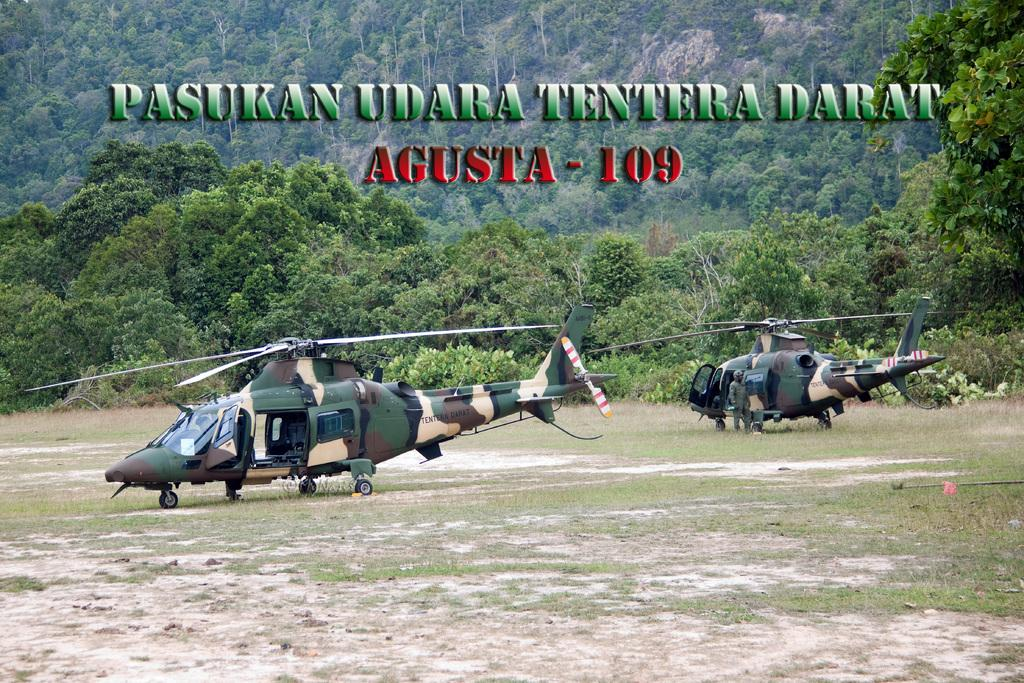What type of vehicles are on the ground in the image? There are two helicopters on the ground in the image. What type of vegetation can be seen in the image? There are green trees visible in the image. Is there any text present in the image? Yes, there is some text present in the image. How many ants are crawling on the helicopter in the image? There are no ants visible in the image; it only features helicopters, green trees, and some text. 